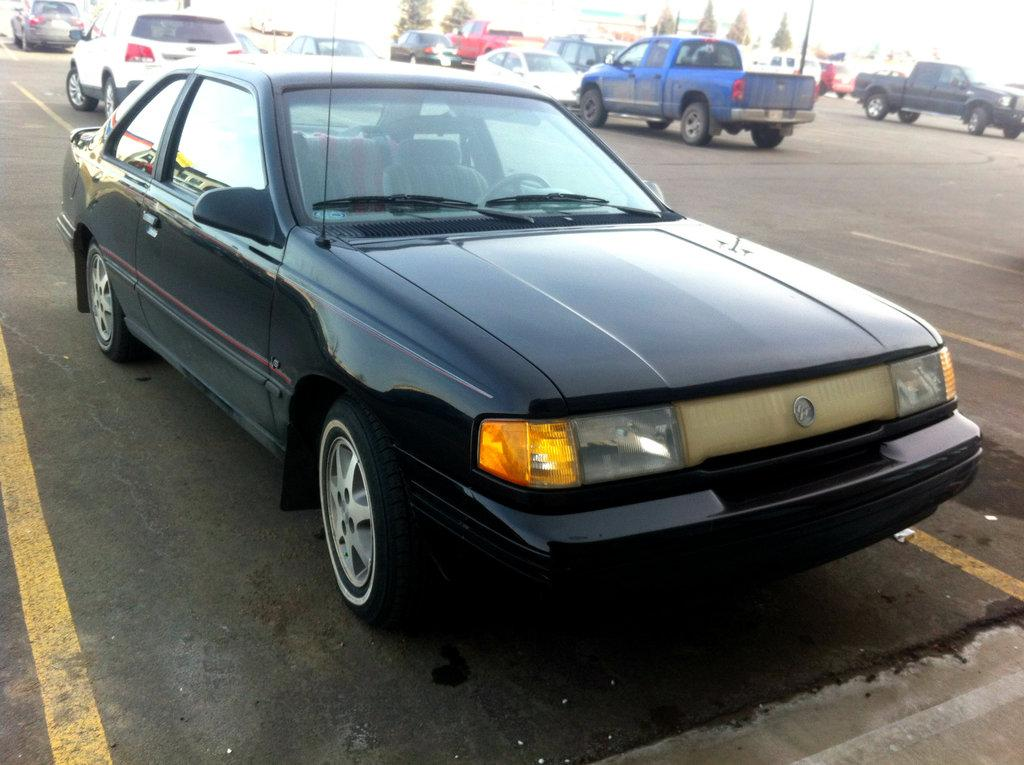What type of vehicles can be seen on the road in the image? There are cars on the road in the image. What can be seen in the background of the image? There are trees visible in the background of the image. How many spiders are crawling on the cars in the image? There are no spiders visible on the cars in the image. What color is the giraffe standing next to the trees in the background? There is no giraffe present in the image; only trees are visible in the background. 